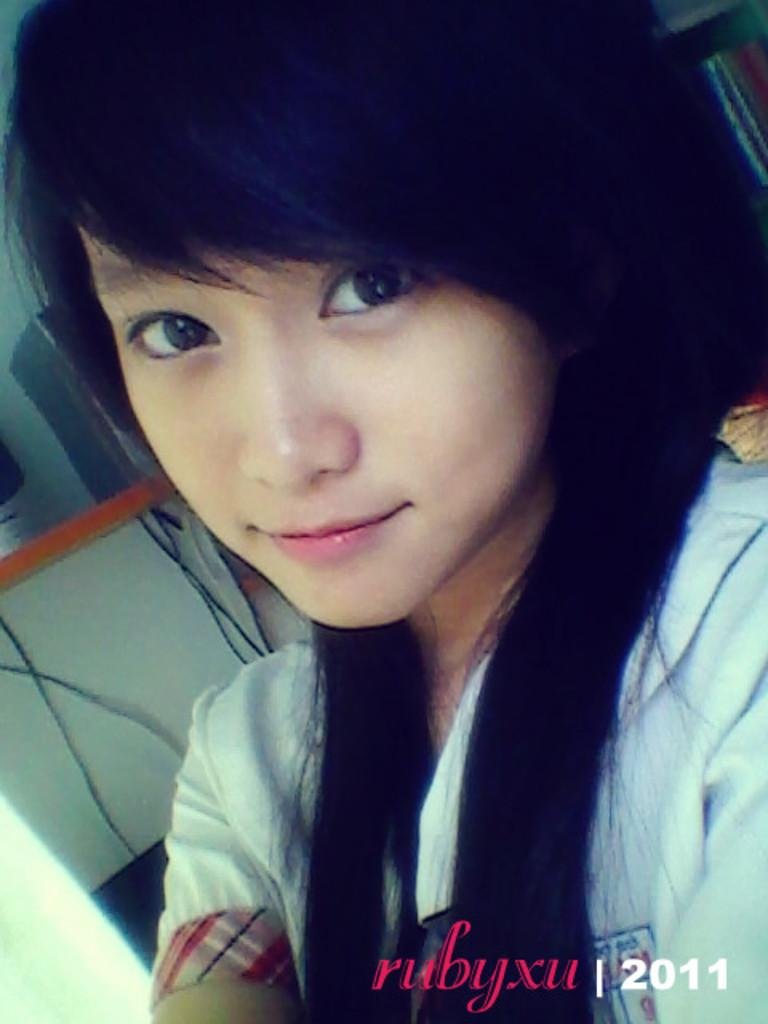Who is the main subject in the foreground of the image? There is a woman in the foreground of the image. What can be seen in the background of the image? There is a table, wires, and other objects in the background of the image. Is there any text present in the image? Yes, there is text at the bottom of the image. How many donkeys are present in the image? There are no donkeys present in the image. What are the girls doing in the image? There are no girls present in the image; it features a woman in the foreground. Is there a boy visible in the image? There is no boy visible in the image; it features a woman in the foreground. 